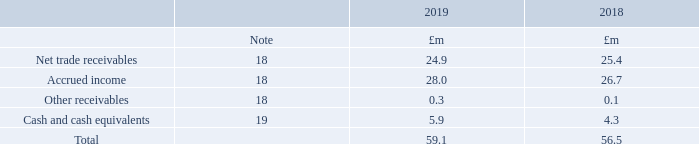31. Financial instruments
Financial assets
What were the total financial assets in 2019?
Answer scale should be: million. 59.1. In which years was the amount of total financial assets calculated? 2019, 2018. What were the components making up the total financial assets in the table? Net trade receivables, accrued income, other receivables, cash and cash equivalents. In which year was the amount of Other receivables larger? 0.3>0.1
Answer: 2019. What was the change in Other receivables in 2019 from 2018?
Answer scale should be: million. 0.3-0.1
Answer: 0.2. What was the percentage change in Other receivables in 2019 from 2018?
Answer scale should be: percent. (0.3-0.1)/0.1
Answer: 200. 